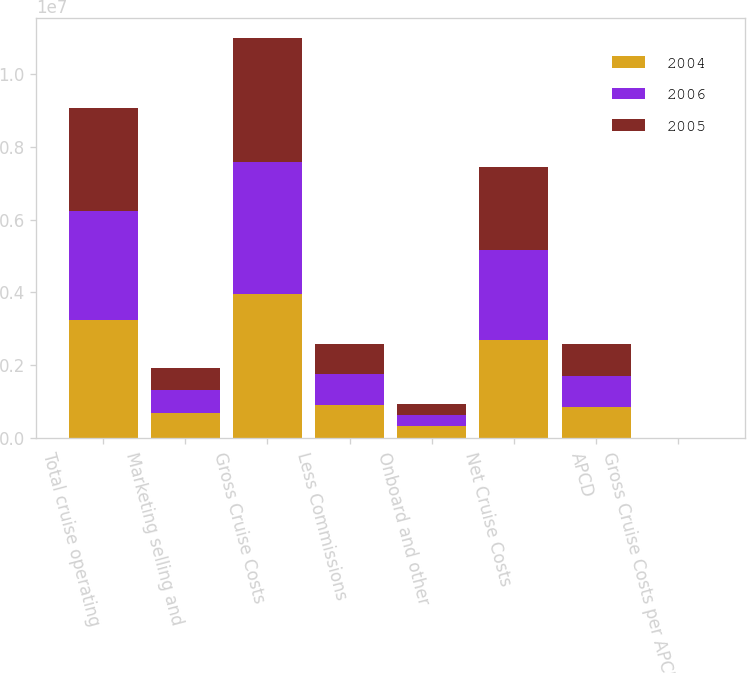Convert chart. <chart><loc_0><loc_0><loc_500><loc_500><stacked_bar_chart><ecel><fcel>Total cruise operating<fcel>Marketing selling and<fcel>Gross Cruise Costs<fcel>Less Commissions<fcel>Onboard and other<fcel>Net Cruise Costs<fcel>APCD<fcel>Gross Cruise Costs per APCD<nl><fcel>2004<fcel>3.24963e+06<fcel>699864<fcel>3.94949e+06<fcel>917929<fcel>331218<fcel>2.70035e+06<fcel>858606<fcel>176.38<nl><fcel>2006<fcel>2.99423e+06<fcel>635308<fcel>3.62954e+06<fcel>858606<fcel>308611<fcel>2.46232e+06<fcel>858606<fcel>167<nl><fcel>2005<fcel>2.81938e+06<fcel>588267<fcel>3.40765e+06<fcel>822206<fcel>300717<fcel>2.28473e+06<fcel>858606<fcel>158.94<nl></chart> 